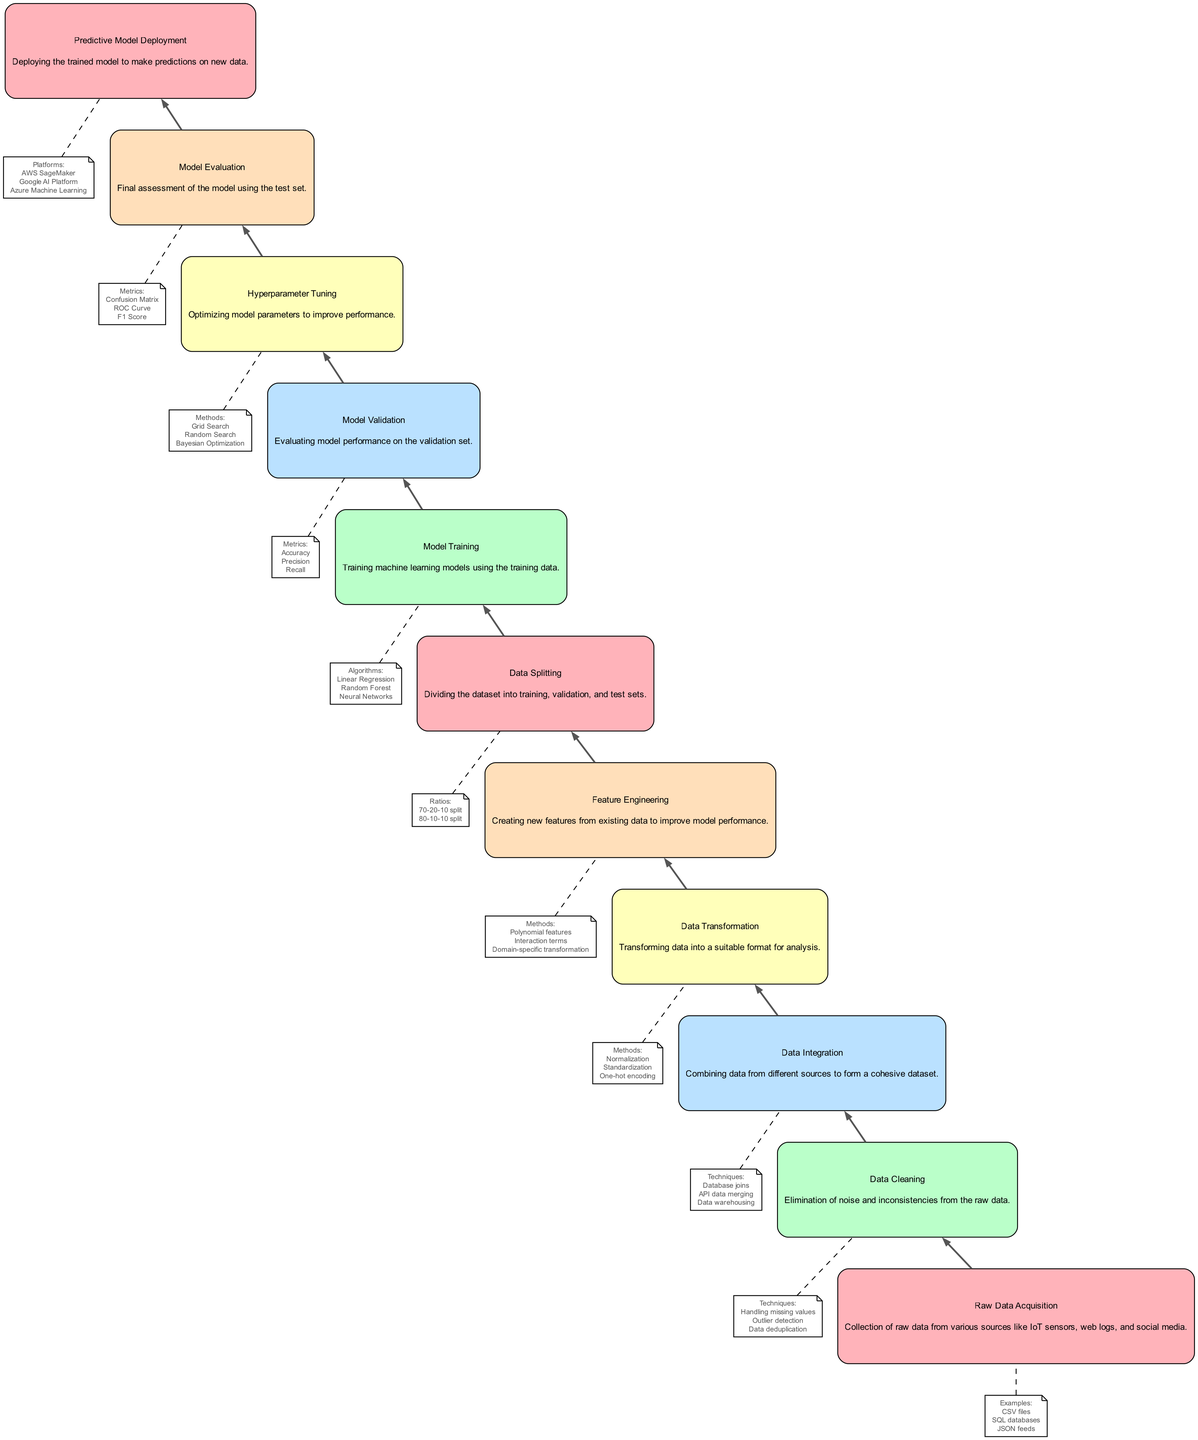What is the starting point of the data transformation journey? The journey starts at the "Raw Data Acquisition" node where data is collected from various sources.
Answer: Raw Data Acquisition How many nodes are in the diagram? By counting all the distinct steps involved in the machine learning pipeline, there are a total of twelve nodes listed.
Answer: Twelve Which node is directly after Data Cleaning? In the flow of information, the node that follows "Data Cleaning" is "Data Integration".
Answer: Data Integration What are the examples mentioned for Raw Data Acquisition? The information provided for "Raw Data Acquisition" includes examples such as CSV files, SQL databases, and JSON feeds.
Answer: CSV files, SQL databases, JSON feeds What type of techniques are used in Data Cleaning? The techniques employed in "Data Cleaning" include handling missing values, outlier detection, and data deduplication.
Answer: Handling missing values, outlier detection, data deduplication What comes before Model Evaluation? The node that precedes "Model Evaluation" in the sequence is "Hyperparameter Tuning", which optimizes model parameters to enhance performance.
Answer: Hyperparameter Tuning How many methods are there for Data Transformation? There are three methods highlighted in the "Data Transformation" stage: Normalization, Standardization, and One-hot encoding, thus resulting in three methods total.
Answer: Three What is the final step in the data transformation journey? The last step represented in the diagram, which signifies the conclusion of the data transformation journey, is "Predictive Model Deployment".
Answer: Predictive Model Deployment Which nodes involve model performance assessment? The nodes that focus on assessing model performance include "Model Validation" and "Model Evaluation".
Answer: Model Validation, Model Evaluation 